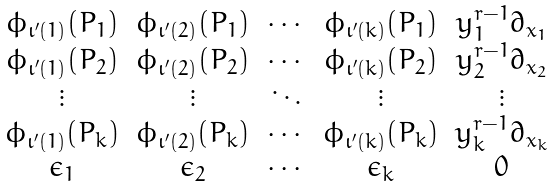<formula> <loc_0><loc_0><loc_500><loc_500>\begin{matrix} \phi _ { \iota ^ { \prime } ( 1 ) } ( P _ { 1 } ) & \phi _ { \iota ^ { \prime } ( 2 ) } ( P _ { 1 } ) & \cdots & \phi _ { \iota ^ { \prime } ( k ) } ( P _ { 1 } ) & y _ { 1 } ^ { r - 1 } \partial _ { x _ { 1 } } \\ \phi _ { \iota ^ { \prime } ( 1 ) } ( P _ { 2 } ) & \phi _ { \iota ^ { \prime } ( 2 ) } ( P _ { 2 } ) & \cdots & \phi _ { \iota ^ { \prime } ( k ) } ( P _ { 2 } ) & y _ { 2 } ^ { r - 1 } \partial _ { x _ { 2 } } \\ \vdots & \vdots & \ddots & \vdots & \vdots \\ \phi _ { \iota ^ { \prime } ( 1 ) } ( P _ { k } ) & \phi _ { \iota ^ { \prime } ( 2 ) } ( P _ { k } ) & \cdots & \phi _ { \iota ^ { \prime } ( k ) } ( P _ { k } ) & y _ { k } ^ { r - 1 } \partial _ { x _ { k } } \\ \epsilon _ { 1 } & \epsilon _ { 2 } & \cdots & \epsilon _ { k } & 0 \end{matrix}</formula> 